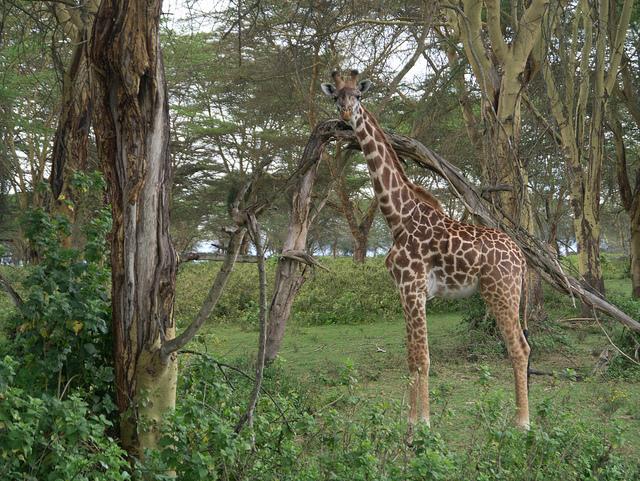What color is the ground?
Keep it brief. Green. Is the giraffe fenced in?
Concise answer only. No. Are the giraffes in their natural habitat?
Short answer required. Yes. What is the giraffe looking at?
Write a very short answer. Camera. Is the giraffe enclosed behind fences?
Keep it brief. No. Are these animals contained?
Concise answer only. No. How many animals are in this photo?
Be succinct. 1. These giraffes live in the wild?
Short answer required. Yes. Is this giraffe in the wild?
Give a very brief answer. Yes. 